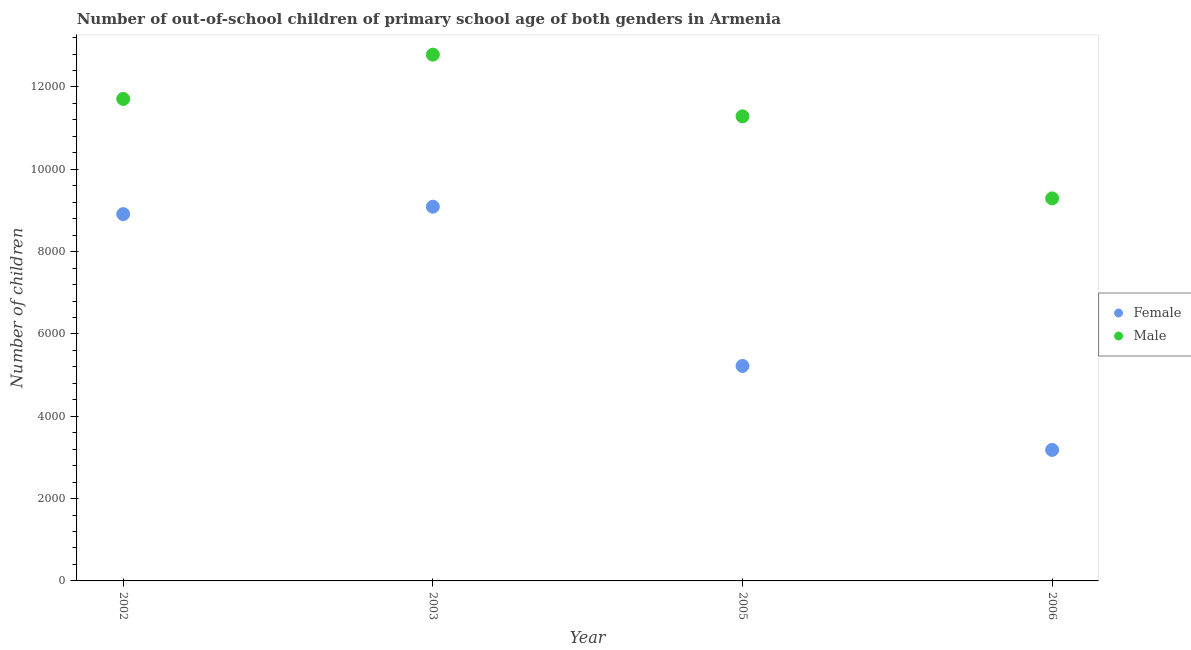Is the number of dotlines equal to the number of legend labels?
Make the answer very short. Yes. What is the number of female out-of-school students in 2003?
Offer a very short reply. 9092. Across all years, what is the maximum number of male out-of-school students?
Your response must be concise. 1.28e+04. Across all years, what is the minimum number of female out-of-school students?
Provide a succinct answer. 3183. In which year was the number of male out-of-school students maximum?
Provide a succinct answer. 2003. What is the total number of female out-of-school students in the graph?
Your answer should be very brief. 2.64e+04. What is the difference between the number of male out-of-school students in 2003 and that in 2005?
Offer a terse response. 1499. What is the difference between the number of male out-of-school students in 2003 and the number of female out-of-school students in 2006?
Your response must be concise. 9603. What is the average number of male out-of-school students per year?
Your answer should be very brief. 1.13e+04. In the year 2006, what is the difference between the number of female out-of-school students and number of male out-of-school students?
Give a very brief answer. -6110. What is the ratio of the number of female out-of-school students in 2005 to that in 2006?
Provide a succinct answer. 1.64. Is the number of female out-of-school students in 2002 less than that in 2006?
Your response must be concise. No. What is the difference between the highest and the second highest number of female out-of-school students?
Make the answer very short. 181. What is the difference between the highest and the lowest number of female out-of-school students?
Offer a terse response. 5909. Does the number of male out-of-school students monotonically increase over the years?
Make the answer very short. No. Is the number of female out-of-school students strictly less than the number of male out-of-school students over the years?
Keep it short and to the point. Yes. How many dotlines are there?
Keep it short and to the point. 2. How many years are there in the graph?
Provide a short and direct response. 4. What is the difference between two consecutive major ticks on the Y-axis?
Give a very brief answer. 2000. Are the values on the major ticks of Y-axis written in scientific E-notation?
Offer a terse response. No. Does the graph contain any zero values?
Make the answer very short. No. Does the graph contain grids?
Your answer should be compact. No. Where does the legend appear in the graph?
Your response must be concise. Center right. How many legend labels are there?
Give a very brief answer. 2. How are the legend labels stacked?
Your answer should be very brief. Vertical. What is the title of the graph?
Offer a very short reply. Number of out-of-school children of primary school age of both genders in Armenia. What is the label or title of the X-axis?
Your answer should be very brief. Year. What is the label or title of the Y-axis?
Give a very brief answer. Number of children. What is the Number of children of Female in 2002?
Your response must be concise. 8911. What is the Number of children in Male in 2002?
Make the answer very short. 1.17e+04. What is the Number of children of Female in 2003?
Your answer should be very brief. 9092. What is the Number of children in Male in 2003?
Make the answer very short. 1.28e+04. What is the Number of children of Female in 2005?
Your response must be concise. 5223. What is the Number of children of Male in 2005?
Provide a succinct answer. 1.13e+04. What is the Number of children in Female in 2006?
Keep it short and to the point. 3183. What is the Number of children in Male in 2006?
Ensure brevity in your answer.  9293. Across all years, what is the maximum Number of children of Female?
Provide a succinct answer. 9092. Across all years, what is the maximum Number of children of Male?
Offer a terse response. 1.28e+04. Across all years, what is the minimum Number of children of Female?
Provide a short and direct response. 3183. Across all years, what is the minimum Number of children of Male?
Keep it short and to the point. 9293. What is the total Number of children of Female in the graph?
Your answer should be very brief. 2.64e+04. What is the total Number of children in Male in the graph?
Make the answer very short. 4.51e+04. What is the difference between the Number of children in Female in 2002 and that in 2003?
Keep it short and to the point. -181. What is the difference between the Number of children of Male in 2002 and that in 2003?
Provide a succinct answer. -1076. What is the difference between the Number of children in Female in 2002 and that in 2005?
Offer a terse response. 3688. What is the difference between the Number of children in Male in 2002 and that in 2005?
Ensure brevity in your answer.  423. What is the difference between the Number of children in Female in 2002 and that in 2006?
Offer a terse response. 5728. What is the difference between the Number of children of Male in 2002 and that in 2006?
Offer a terse response. 2417. What is the difference between the Number of children in Female in 2003 and that in 2005?
Make the answer very short. 3869. What is the difference between the Number of children in Male in 2003 and that in 2005?
Offer a terse response. 1499. What is the difference between the Number of children in Female in 2003 and that in 2006?
Your answer should be very brief. 5909. What is the difference between the Number of children in Male in 2003 and that in 2006?
Keep it short and to the point. 3493. What is the difference between the Number of children of Female in 2005 and that in 2006?
Provide a succinct answer. 2040. What is the difference between the Number of children of Male in 2005 and that in 2006?
Your response must be concise. 1994. What is the difference between the Number of children of Female in 2002 and the Number of children of Male in 2003?
Ensure brevity in your answer.  -3875. What is the difference between the Number of children in Female in 2002 and the Number of children in Male in 2005?
Your answer should be very brief. -2376. What is the difference between the Number of children of Female in 2002 and the Number of children of Male in 2006?
Your answer should be compact. -382. What is the difference between the Number of children of Female in 2003 and the Number of children of Male in 2005?
Your answer should be very brief. -2195. What is the difference between the Number of children of Female in 2003 and the Number of children of Male in 2006?
Keep it short and to the point. -201. What is the difference between the Number of children of Female in 2005 and the Number of children of Male in 2006?
Offer a very short reply. -4070. What is the average Number of children in Female per year?
Make the answer very short. 6602.25. What is the average Number of children in Male per year?
Offer a very short reply. 1.13e+04. In the year 2002, what is the difference between the Number of children in Female and Number of children in Male?
Your response must be concise. -2799. In the year 2003, what is the difference between the Number of children of Female and Number of children of Male?
Your answer should be very brief. -3694. In the year 2005, what is the difference between the Number of children in Female and Number of children in Male?
Provide a short and direct response. -6064. In the year 2006, what is the difference between the Number of children of Female and Number of children of Male?
Give a very brief answer. -6110. What is the ratio of the Number of children of Female in 2002 to that in 2003?
Offer a very short reply. 0.98. What is the ratio of the Number of children of Male in 2002 to that in 2003?
Provide a succinct answer. 0.92. What is the ratio of the Number of children in Female in 2002 to that in 2005?
Your answer should be very brief. 1.71. What is the ratio of the Number of children of Male in 2002 to that in 2005?
Your answer should be very brief. 1.04. What is the ratio of the Number of children of Female in 2002 to that in 2006?
Offer a very short reply. 2.8. What is the ratio of the Number of children in Male in 2002 to that in 2006?
Your answer should be very brief. 1.26. What is the ratio of the Number of children in Female in 2003 to that in 2005?
Your response must be concise. 1.74. What is the ratio of the Number of children in Male in 2003 to that in 2005?
Give a very brief answer. 1.13. What is the ratio of the Number of children in Female in 2003 to that in 2006?
Provide a short and direct response. 2.86. What is the ratio of the Number of children in Male in 2003 to that in 2006?
Your response must be concise. 1.38. What is the ratio of the Number of children in Female in 2005 to that in 2006?
Provide a short and direct response. 1.64. What is the ratio of the Number of children in Male in 2005 to that in 2006?
Provide a succinct answer. 1.21. What is the difference between the highest and the second highest Number of children of Female?
Provide a succinct answer. 181. What is the difference between the highest and the second highest Number of children in Male?
Provide a short and direct response. 1076. What is the difference between the highest and the lowest Number of children in Female?
Your answer should be very brief. 5909. What is the difference between the highest and the lowest Number of children in Male?
Offer a terse response. 3493. 